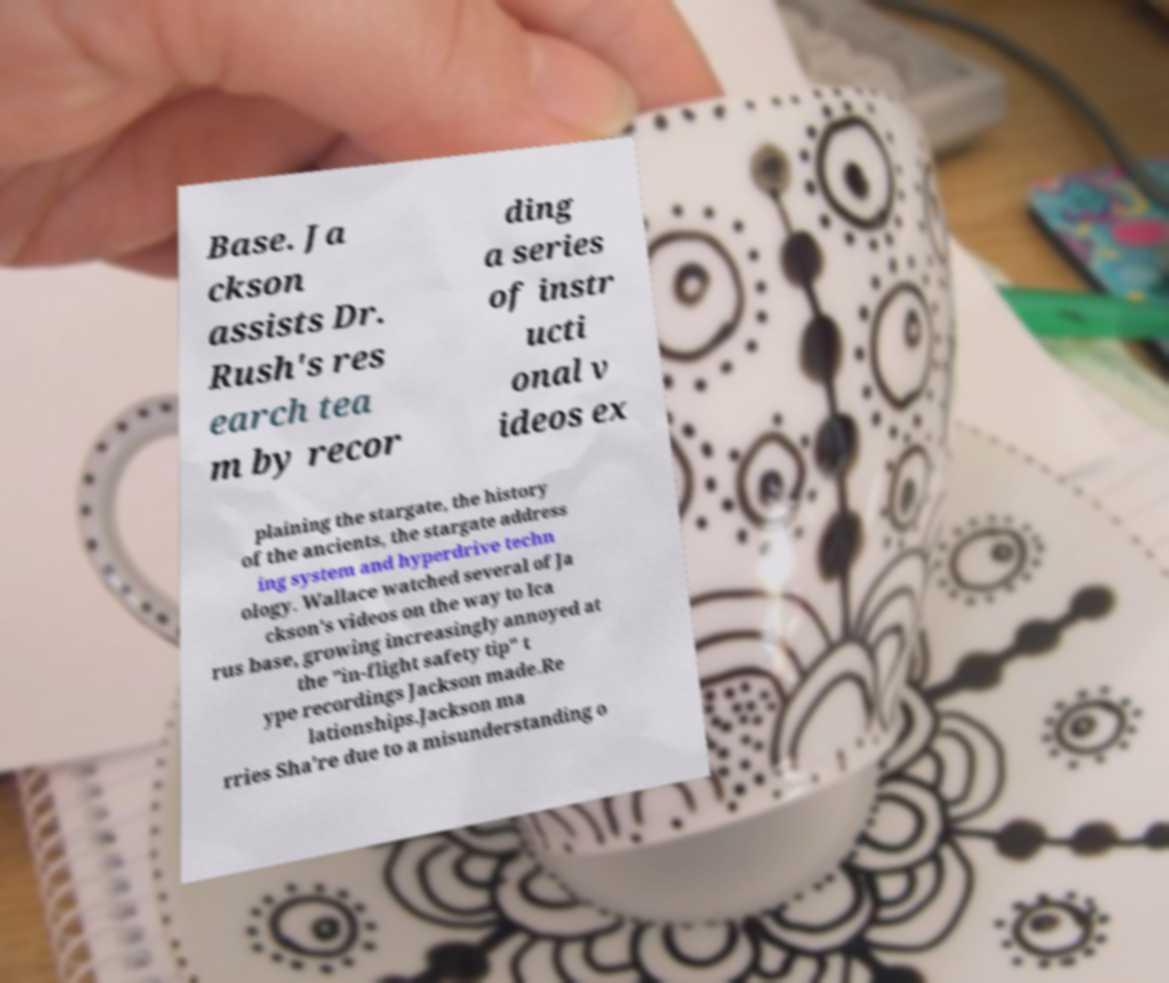Could you extract and type out the text from this image? Base. Ja ckson assists Dr. Rush's res earch tea m by recor ding a series of instr ucti onal v ideos ex plaining the stargate, the history of the ancients, the stargate address ing system and hyperdrive techn ology. Wallace watched several of Ja ckson's videos on the way to Ica rus base, growing increasingly annoyed at the "in-flight safety tip" t ype recordings Jackson made.Re lationships.Jackson ma rries Sha're due to a misunderstanding o 